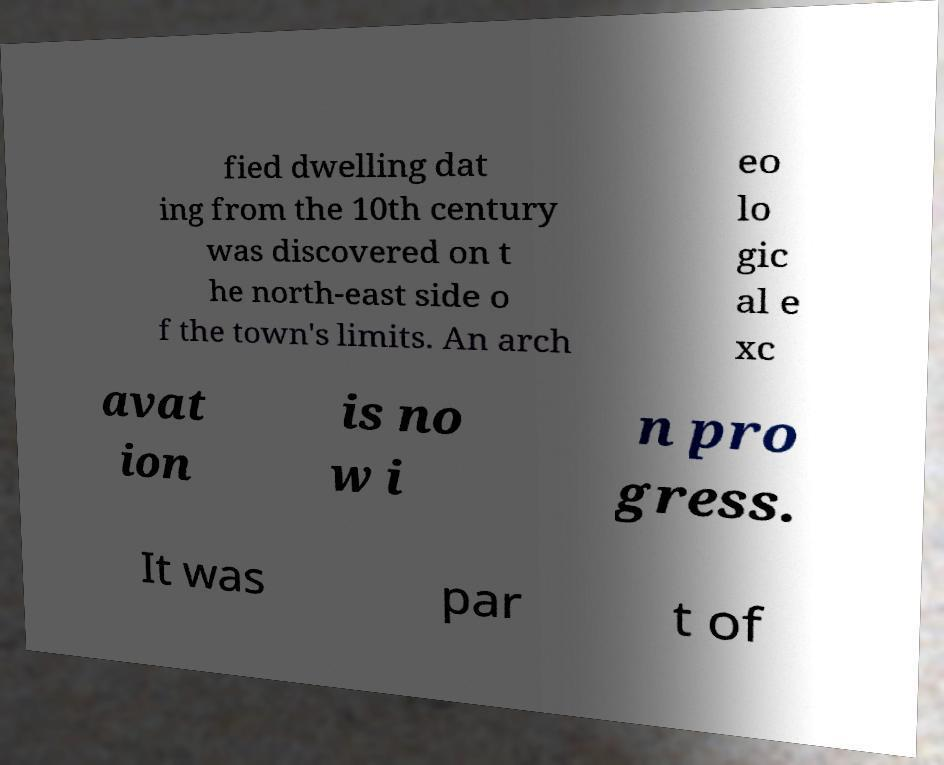Please identify and transcribe the text found in this image. fied dwelling dat ing from the 10th century was discovered on t he north-east side o f the town's limits. An arch eo lo gic al e xc avat ion is no w i n pro gress. It was par t of 